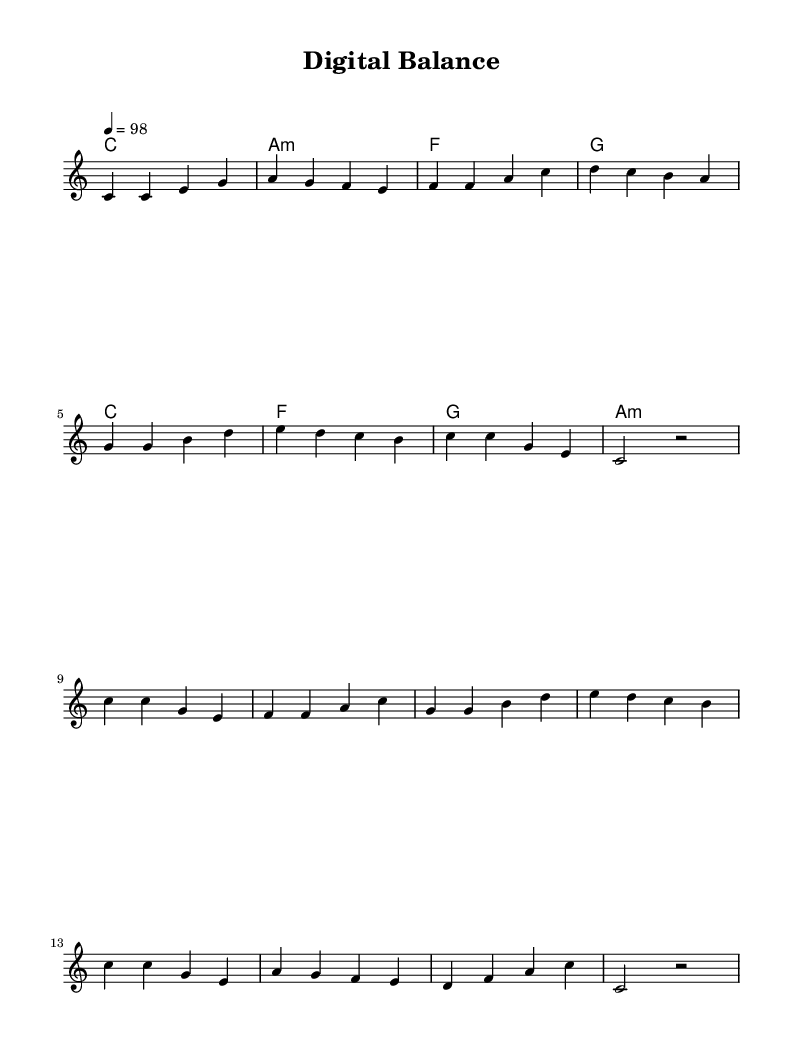What is the key signature of this music? The key signature indicated in the global section is C major, which means there are no sharps or flats used in the music.
Answer: C major What is the time signature of the piece? The time signature written in the global section is 4/4, which means that there are four beats per measure and the quarter note receives one beat.
Answer: 4/4 What is the tempo marking of the song? The tempo marking provided in the global section is 4 = 98, which indicates there are 98 beats per minute, and the note value used is a quarter note.
Answer: 98 How many measures are in the verse? The verse section consists of 8 measures, as counted by each group of notes separated by the vertical lines.
Answer: 8 What is the primary theme of the lyrics? The lyrics focus on the balance and responsibility in using technology wisely in our daily lives, emphasizing that it should be used for good rather than just for personal gain.
Answer: Digital balance What type of harmony is used in the verse? The harmony for the verse consists of simple triads played on the chords: C major, A minor, F major, and G major, which are typical in reggae music for creating a rich yet straightforward sound.
Answer: Triads What is the chorus's repetitive hook? The chorus frequently repeats the phrase about needing digital balance and using technology responsibly, encapsulating the main message of the song in a catchy format typical for reggae songs.
Answer: Digital balance 